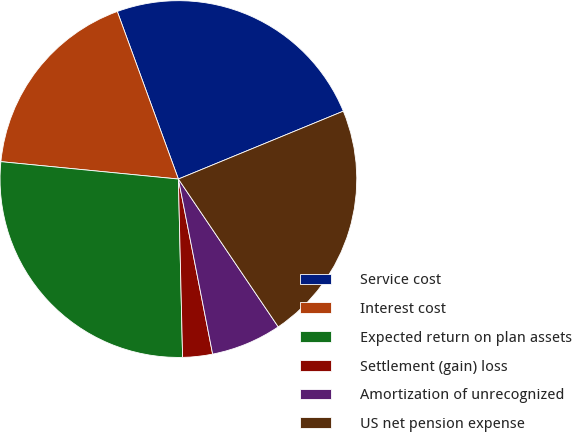Convert chart to OTSL. <chart><loc_0><loc_0><loc_500><loc_500><pie_chart><fcel>Service cost<fcel>Interest cost<fcel>Expected return on plan assets<fcel>Settlement (gain) loss<fcel>Amortization of unrecognized<fcel>US net pension expense<nl><fcel>24.35%<fcel>17.88%<fcel>26.93%<fcel>2.7%<fcel>6.38%<fcel>21.76%<nl></chart> 